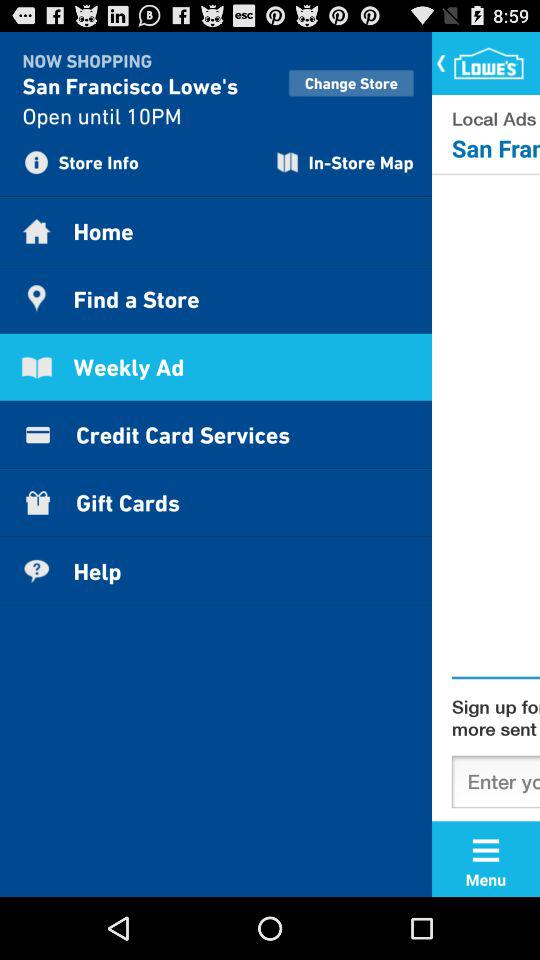Which option has been selected? The option which has been selected is "Weekly Ad". 